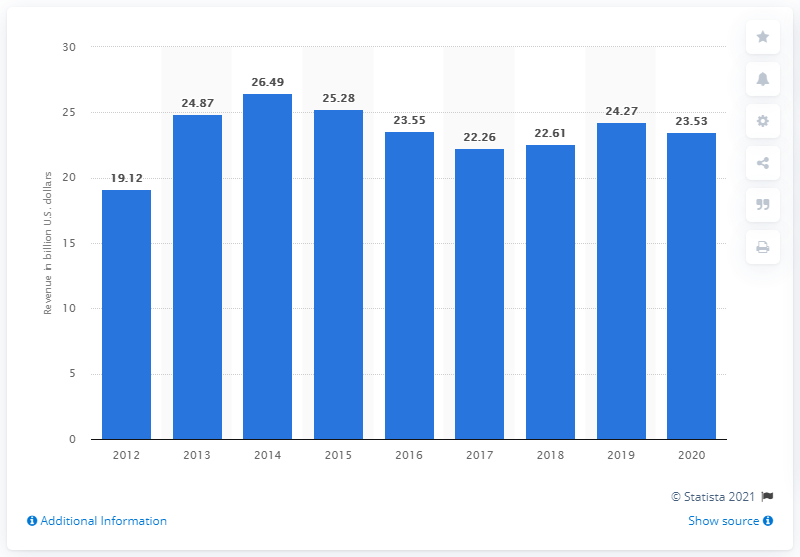Outline some significant characteristics in this image. Qualcomm generated revenue of approximately 23.53 billion USD in the 2020 fiscal year. 